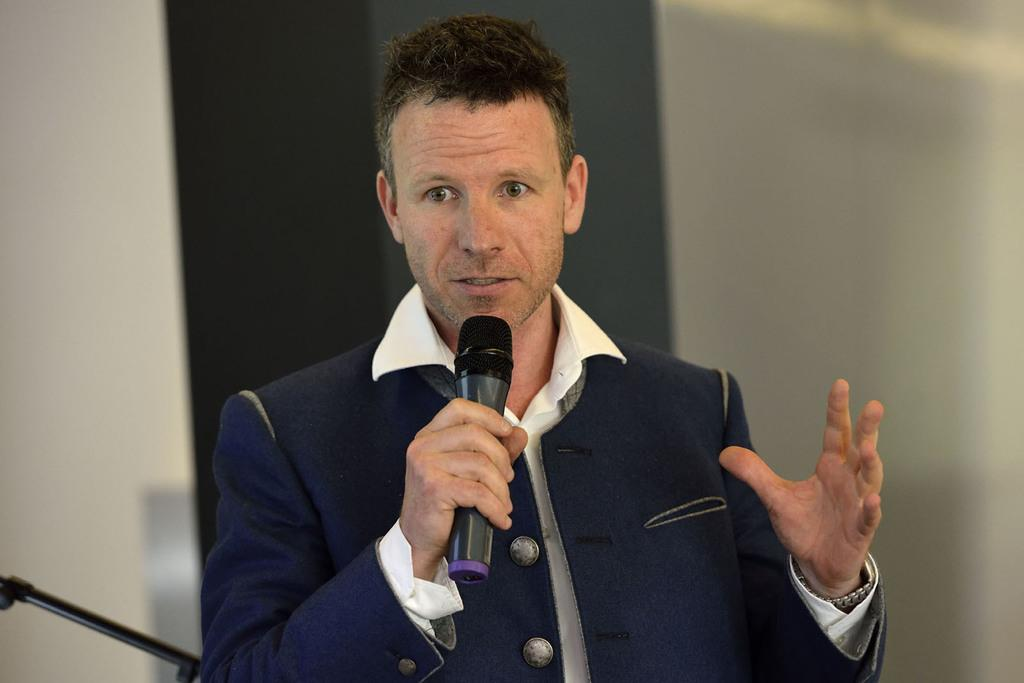Who is the main subject in the image? There is a man in the image. What is the man doing in the image? The man is talking on a mic. What can be seen behind the man in the image? There is a wall behind the man. Can you see a road in the image? No, there is no road visible in the image. Is the man in the image cooking anything? No, the man is not cooking anything in the image; he is talking on a mic. 